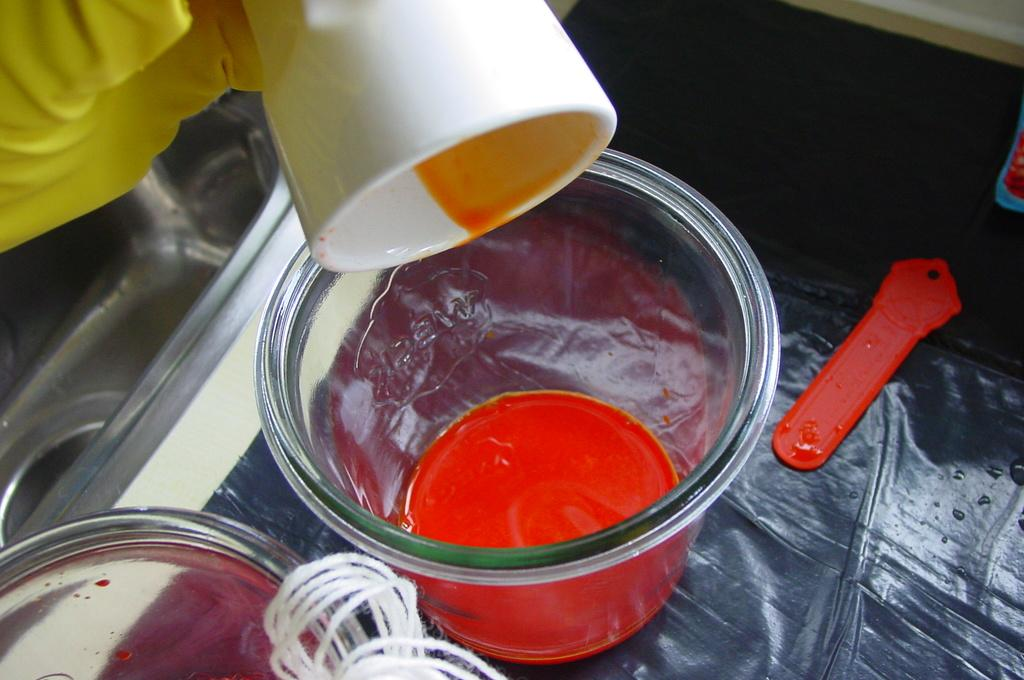What type of containers are present in the image? There are bowls in the image. Can you describe the color of one of the cups in the image? There is a white color cup in the image. What else can be seen on the surface in the image? There are other objects on the surface in the image. What type of current is flowing through the objects in the image? There is no indication of any current flowing through the objects in the image. 